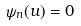Convert formula to latex. <formula><loc_0><loc_0><loc_500><loc_500>\psi _ { n } ( u ) = 0</formula> 